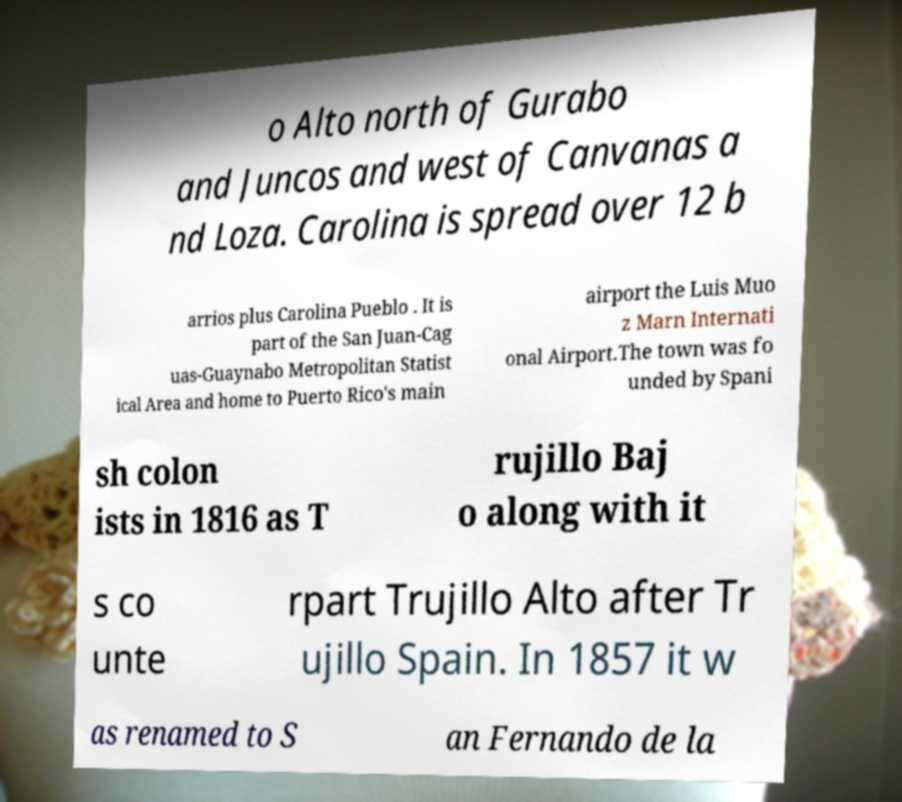I need the written content from this picture converted into text. Can you do that? o Alto north of Gurabo and Juncos and west of Canvanas a nd Loza. Carolina is spread over 12 b arrios plus Carolina Pueblo . It is part of the San Juan-Cag uas-Guaynabo Metropolitan Statist ical Area and home to Puerto Rico's main airport the Luis Muo z Marn Internati onal Airport.The town was fo unded by Spani sh colon ists in 1816 as T rujillo Baj o along with it s co unte rpart Trujillo Alto after Tr ujillo Spain. In 1857 it w as renamed to S an Fernando de la 